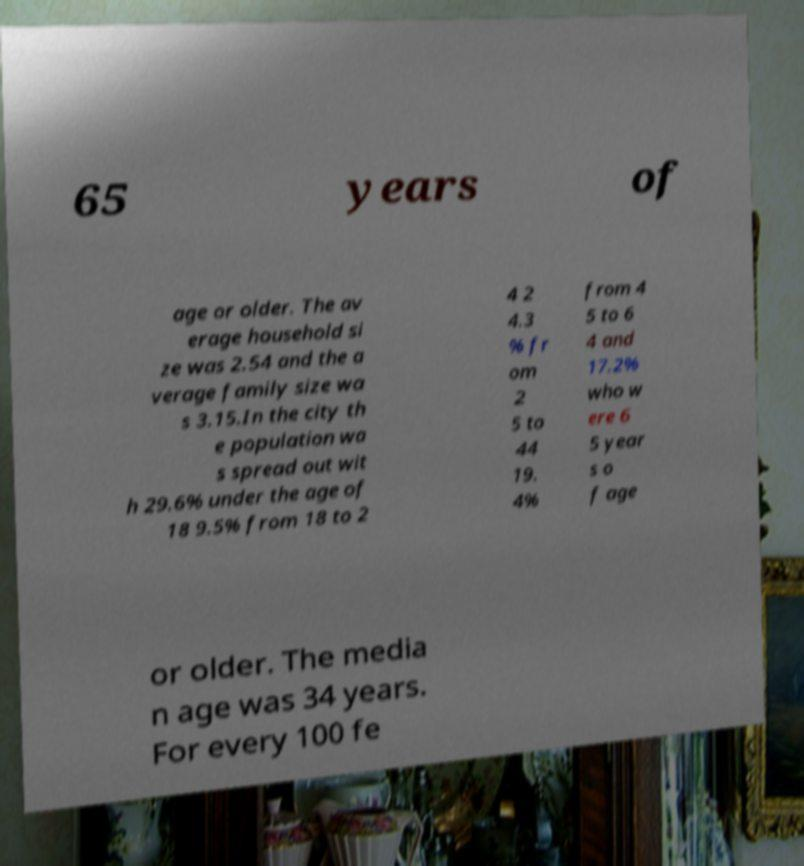What messages or text are displayed in this image? I need them in a readable, typed format. 65 years of age or older. The av erage household si ze was 2.54 and the a verage family size wa s 3.15.In the city th e population wa s spread out wit h 29.6% under the age of 18 9.5% from 18 to 2 4 2 4.3 % fr om 2 5 to 44 19. 4% from 4 5 to 6 4 and 17.2% who w ere 6 5 year s o f age or older. The media n age was 34 years. For every 100 fe 